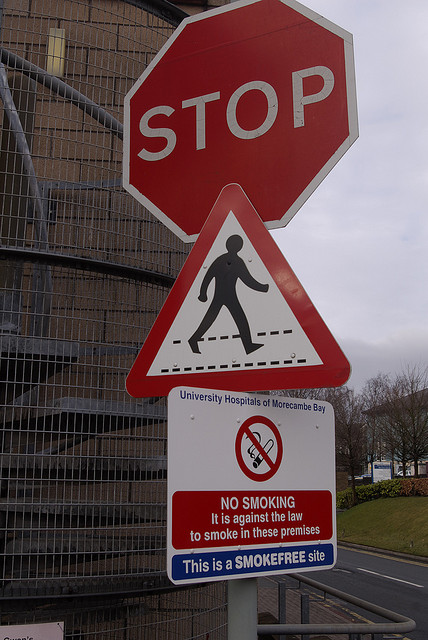Please identify all text content in this image. STOP NO SMOKING SMOKEFREE site a is this premises these in smoke to law the against is It Bay Morecambe of Hospitals University 